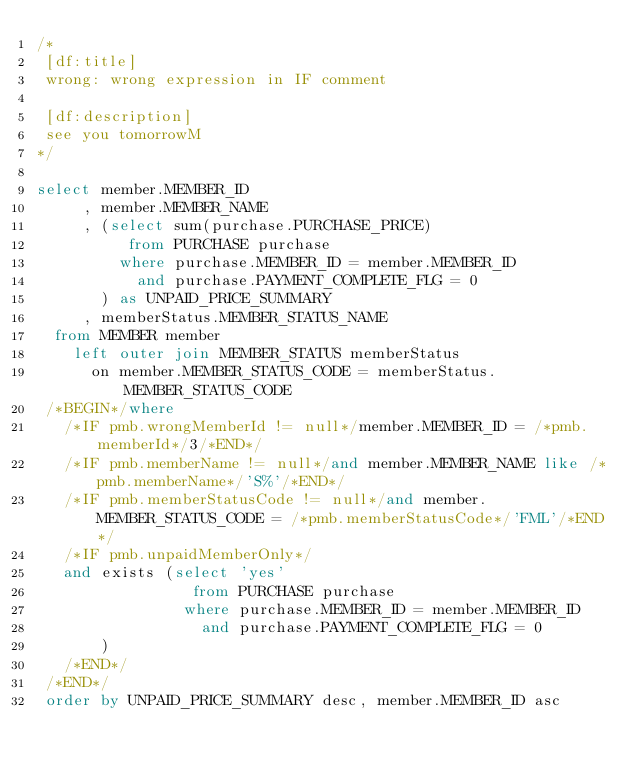<code> <loc_0><loc_0><loc_500><loc_500><_SQL_>/*
 [df:title]
 wrong: wrong expression in IF comment
 
 [df:description]
 see you tomorrowM
*/

select member.MEMBER_ID
     , member.MEMBER_NAME
     , (select sum(purchase.PURCHASE_PRICE)
          from PURCHASE purchase
         where purchase.MEMBER_ID = member.MEMBER_ID
           and purchase.PAYMENT_COMPLETE_FLG = 0
       ) as UNPAID_PRICE_SUMMARY
     , memberStatus.MEMBER_STATUS_NAME
  from MEMBER member
    left outer join MEMBER_STATUS memberStatus
      on member.MEMBER_STATUS_CODE = memberStatus.MEMBER_STATUS_CODE
 /*BEGIN*/where
   /*IF pmb.wrongMemberId != null*/member.MEMBER_ID = /*pmb.memberId*/3/*END*/
   /*IF pmb.memberName != null*/and member.MEMBER_NAME like /*pmb.memberName*/'S%'/*END*/
   /*IF pmb.memberStatusCode != null*/and member.MEMBER_STATUS_CODE = /*pmb.memberStatusCode*/'FML'/*END*/
   /*IF pmb.unpaidMemberOnly*/
   and exists (select 'yes'
                 from PURCHASE purchase
                where purchase.MEMBER_ID = member.MEMBER_ID
                  and purchase.PAYMENT_COMPLETE_FLG = 0
       )
   /*END*/
 /*END*/
 order by UNPAID_PRICE_SUMMARY desc, member.MEMBER_ID asc
</code> 